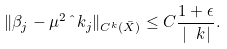Convert formula to latex. <formula><loc_0><loc_0><loc_500><loc_500>\| \beta _ { j } - \mu ^ { 2 } \hat { \ } k _ { j } \| _ { C ^ { k } ( \bar { X } ) } \leq C \frac { 1 + \epsilon } { | \ k | } .</formula> 